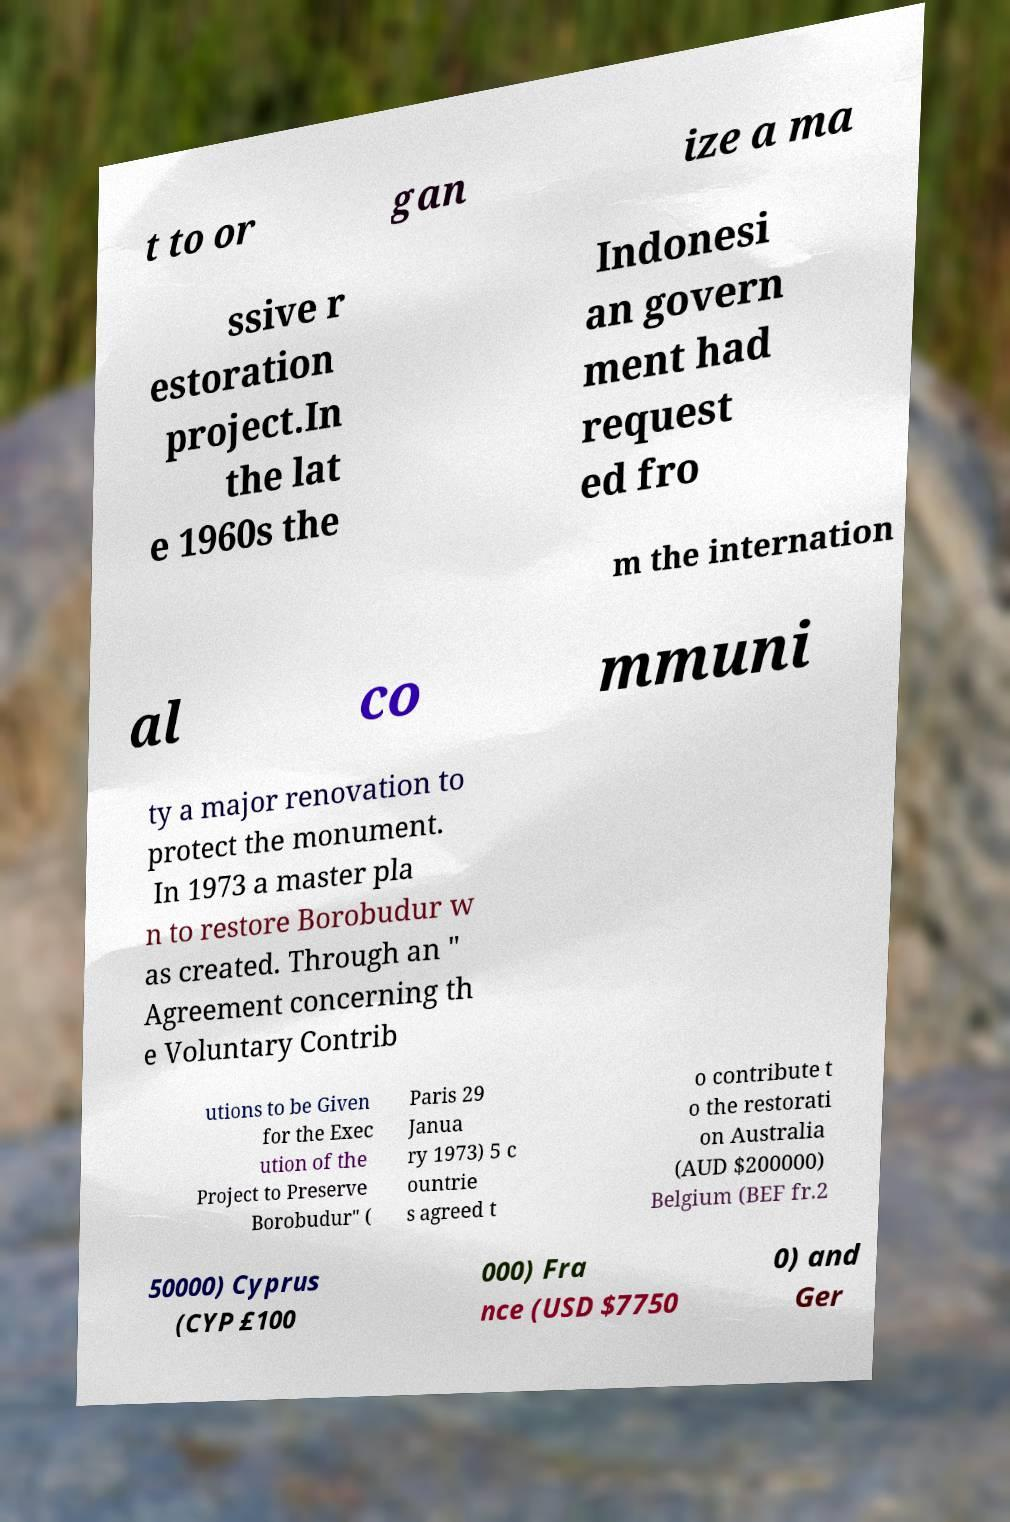There's text embedded in this image that I need extracted. Can you transcribe it verbatim? t to or gan ize a ma ssive r estoration project.In the lat e 1960s the Indonesi an govern ment had request ed fro m the internation al co mmuni ty a major renovation to protect the monument. In 1973 a master pla n to restore Borobudur w as created. Through an " Agreement concerning th e Voluntary Contrib utions to be Given for the Exec ution of the Project to Preserve Borobudur" ( Paris 29 Janua ry 1973) 5 c ountrie s agreed t o contribute t o the restorati on Australia (AUD $200000) Belgium (BEF fr.2 50000) Cyprus (CYP £100 000) Fra nce (USD $7750 0) and Ger 